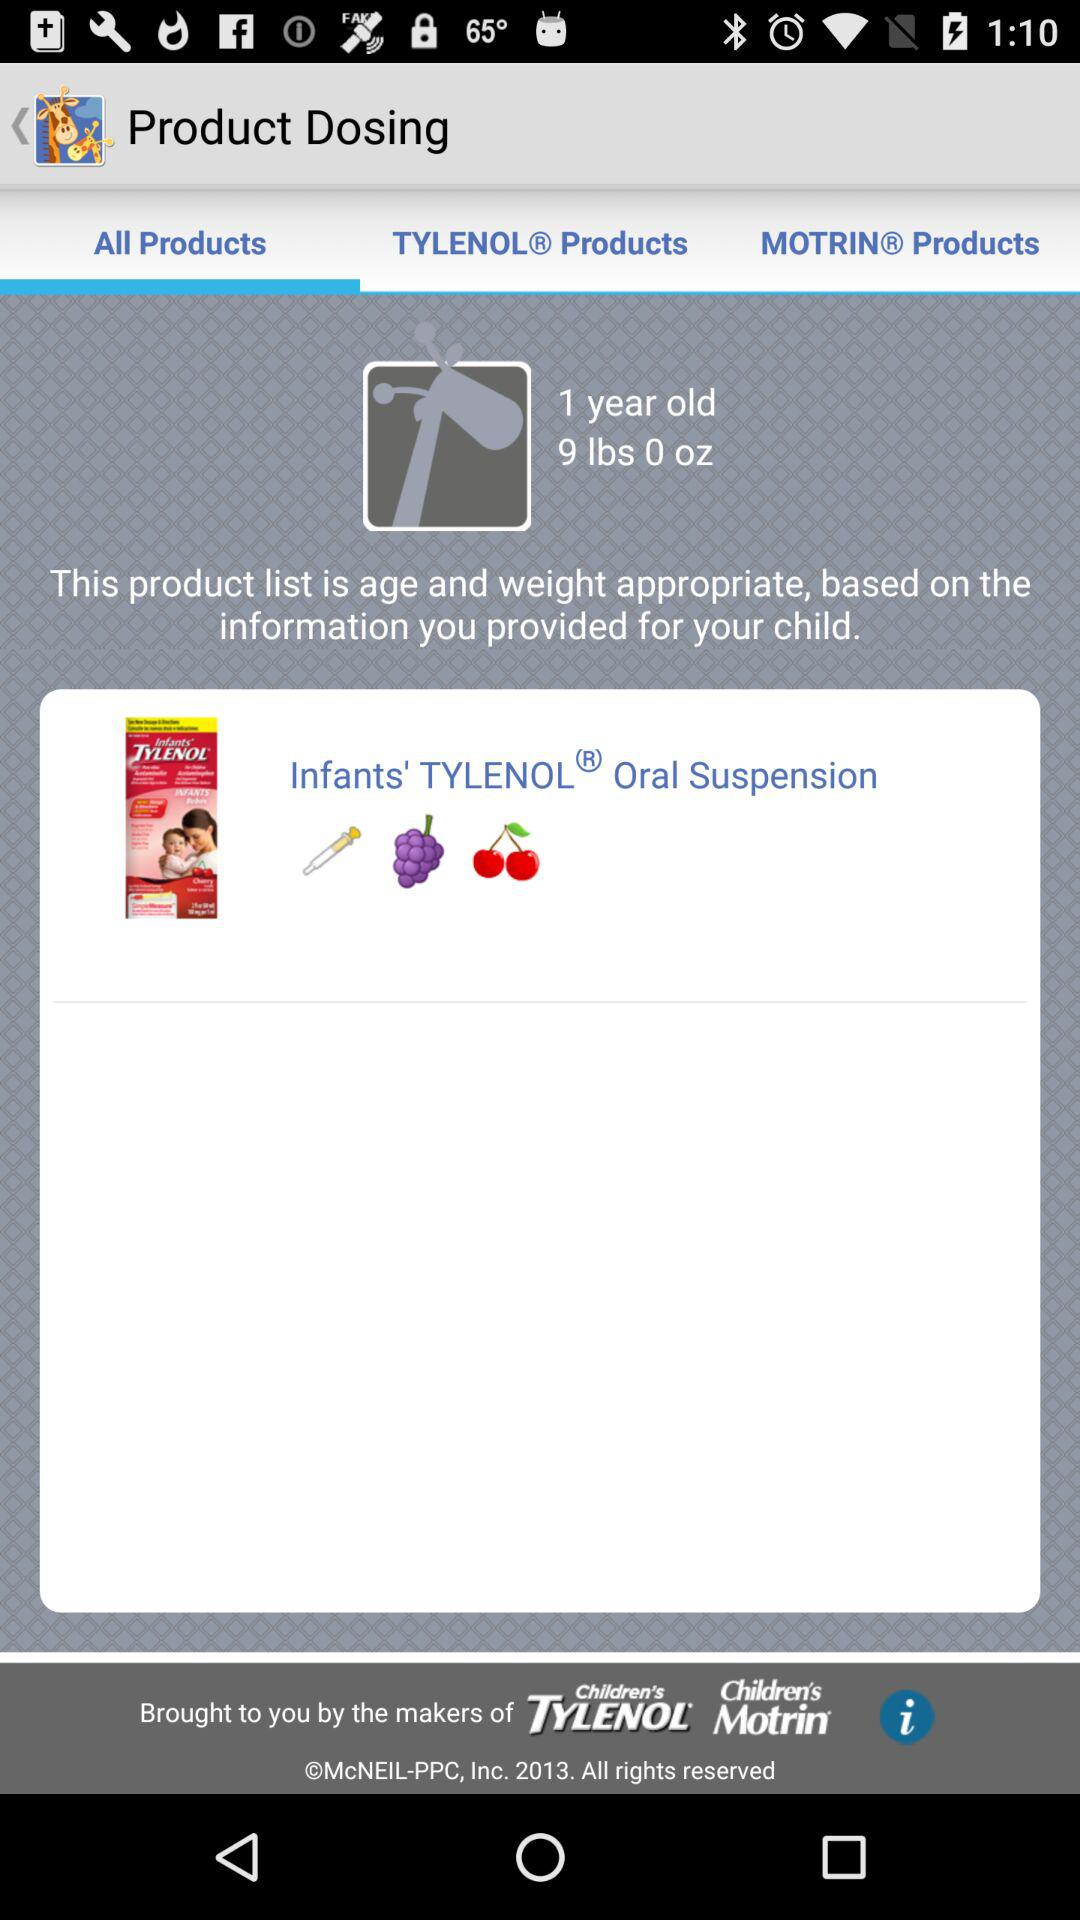What is the app name? The app name is "Kids' Wellness Tracker". 